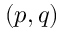Convert formula to latex. <formula><loc_0><loc_0><loc_500><loc_500>( p , q )</formula> 